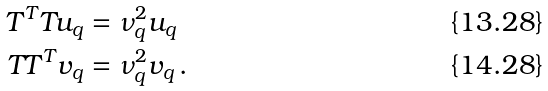<formula> <loc_0><loc_0><loc_500><loc_500>T ^ { T } T u _ { q } & = \nu _ { q } ^ { 2 } u _ { q } \\ T T ^ { T } v _ { q } & = \nu _ { q } ^ { 2 } v _ { q } \, .</formula> 